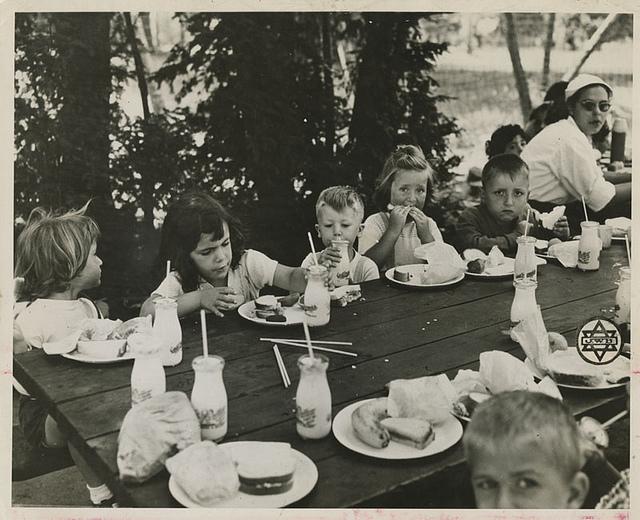Are they eating sandwiches?
Write a very short answer. Yes. Is this a typical use for these items?
Be succinct. Yes. What are the straws for?
Quick response, please. Drinking. Is this black and white?
Give a very brief answer. Yes. 